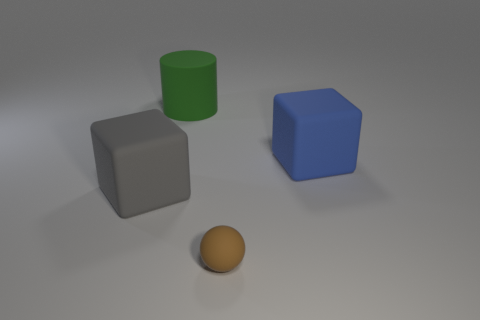Add 1 small rubber objects. How many objects exist? 5 Add 1 brown matte objects. How many brown matte objects are left? 2 Add 1 small objects. How many small objects exist? 2 Subtract 0 cyan cylinders. How many objects are left? 4 Subtract all big gray things. Subtract all balls. How many objects are left? 2 